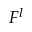<formula> <loc_0><loc_0><loc_500><loc_500>F ^ { l }</formula> 